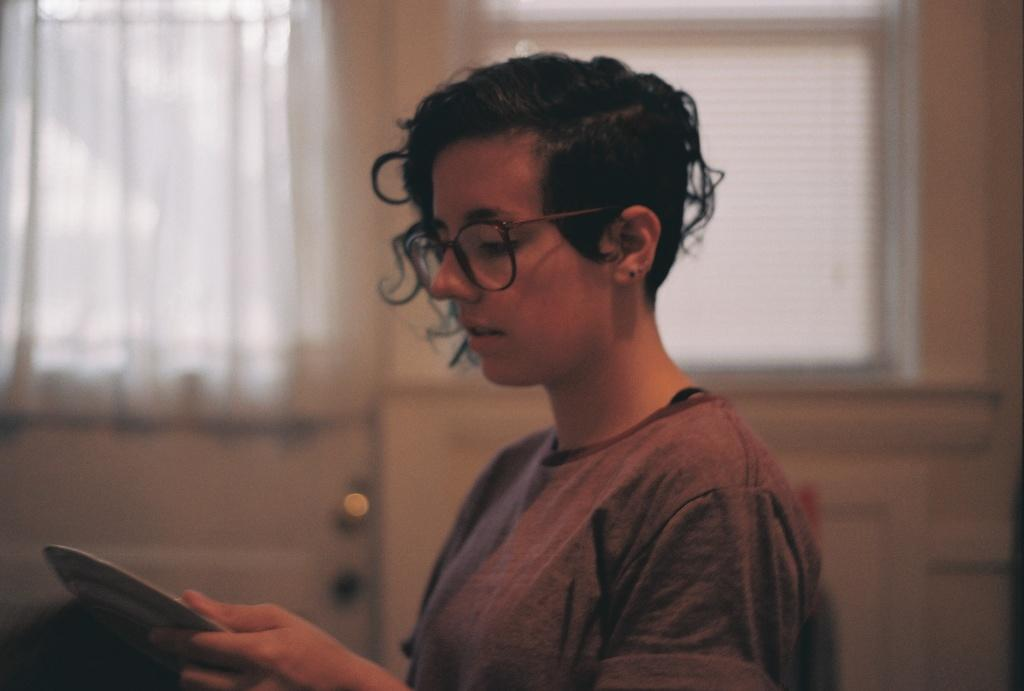Who is the main subject in the image? There is a girl in the image. What is the girl doing in the image? The girl is standing in the front and looking into a book. What can be seen in the background of the image? There is a window in the background. What type of window treatment is present in the image? White curtains are associated with the window. What type of pear can be seen hanging from the window in the image? There is no pear present in the image, and therefore no such object can be observed hanging from the window. 